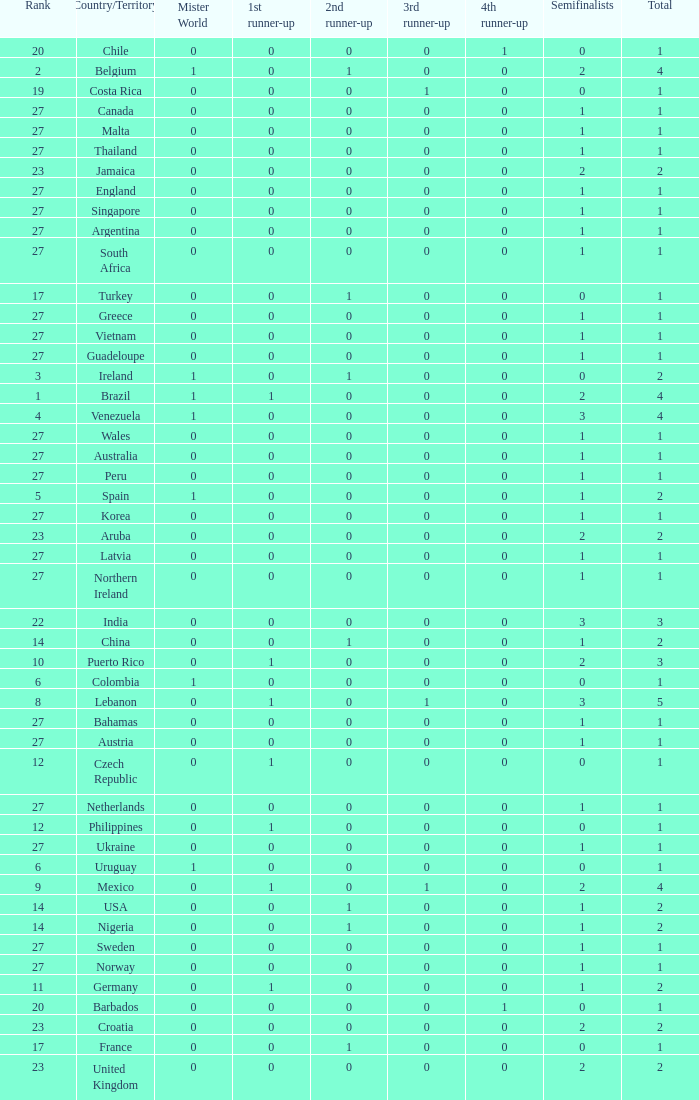What is the count of 1st runner-up positions held by jamaica? 1.0. 